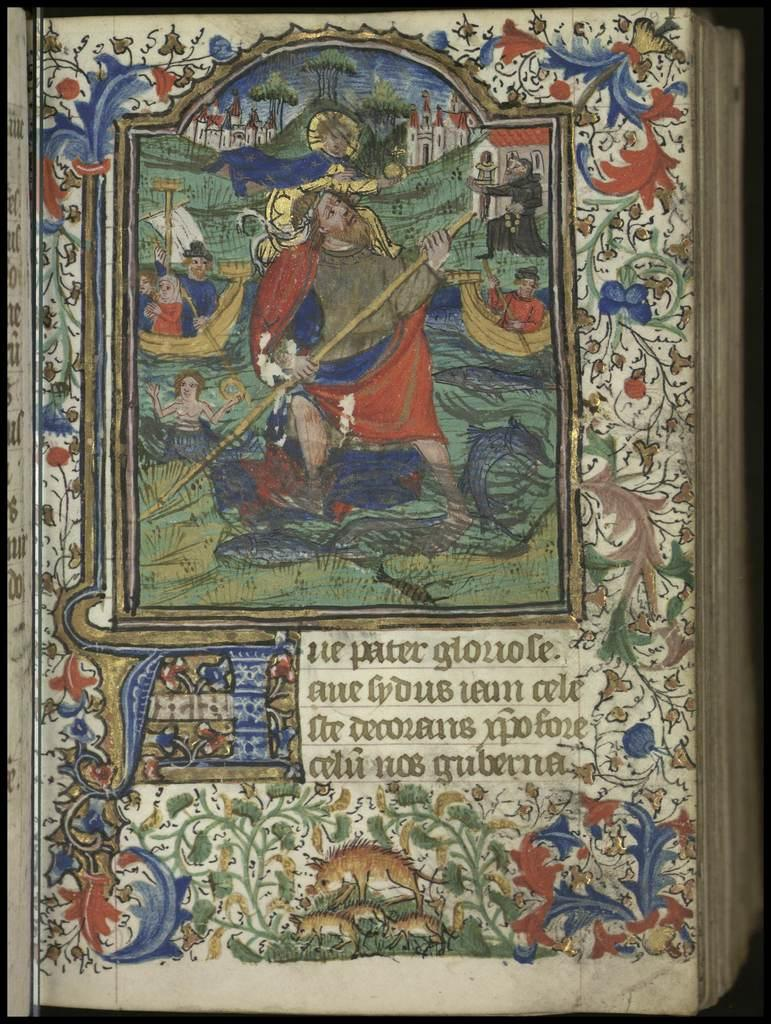<image>
Describe the image concisely. The blue red and white book features a man named Peter. 